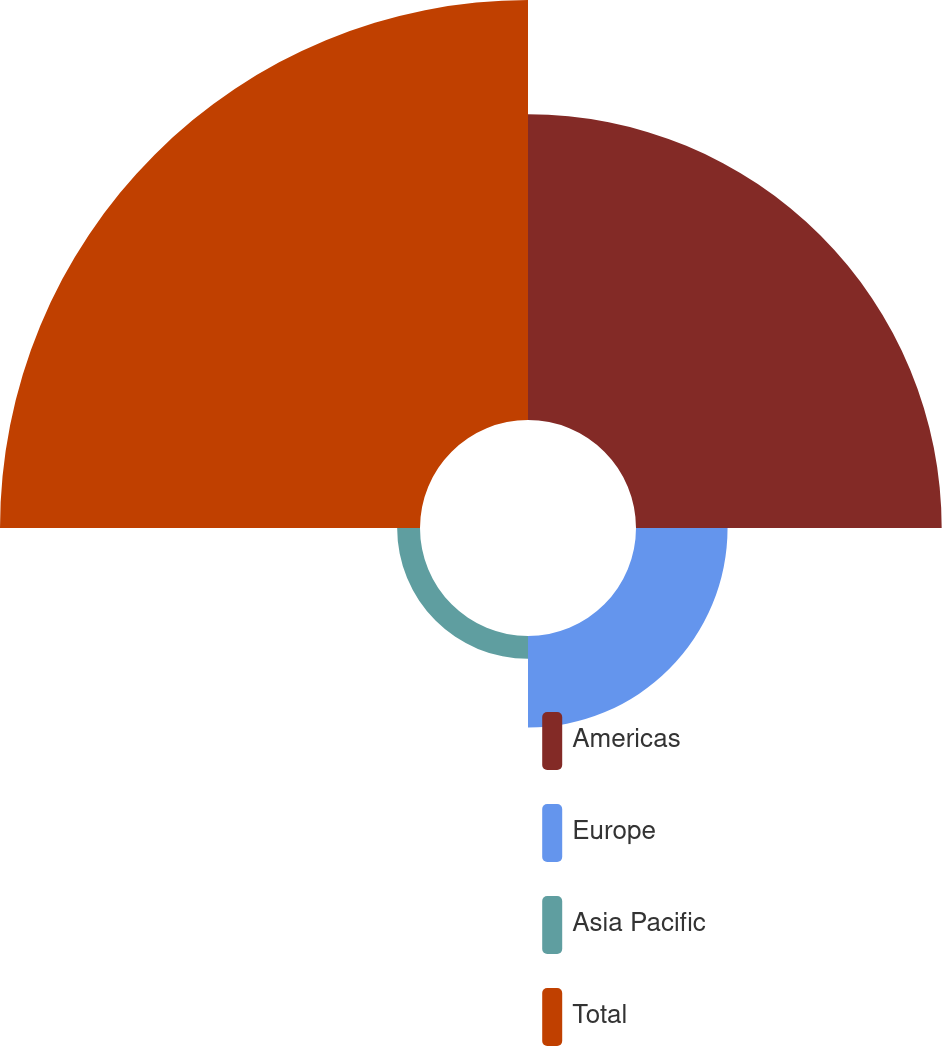<chart> <loc_0><loc_0><loc_500><loc_500><pie_chart><fcel>Americas<fcel>Europe<fcel>Asia Pacific<fcel>Total<nl><fcel>36.39%<fcel>10.9%<fcel>2.72%<fcel>50.0%<nl></chart> 